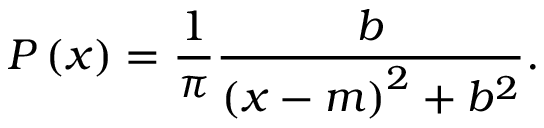Convert formula to latex. <formula><loc_0><loc_0><loc_500><loc_500>P \left ( x \right ) = \frac { 1 } { \pi } \frac { b } { \left ( x - m \right ) ^ { 2 } + b ^ { 2 } } .</formula> 